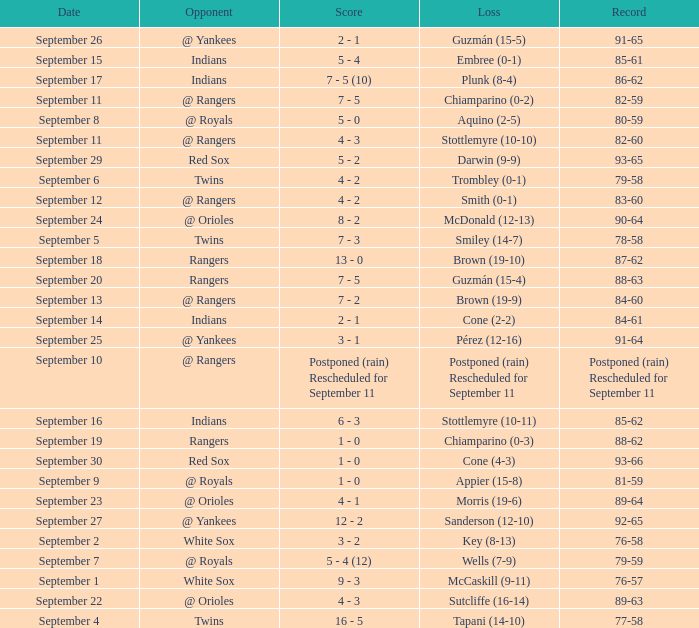What's the loss for September 16? Stottlemyre (10-11). 